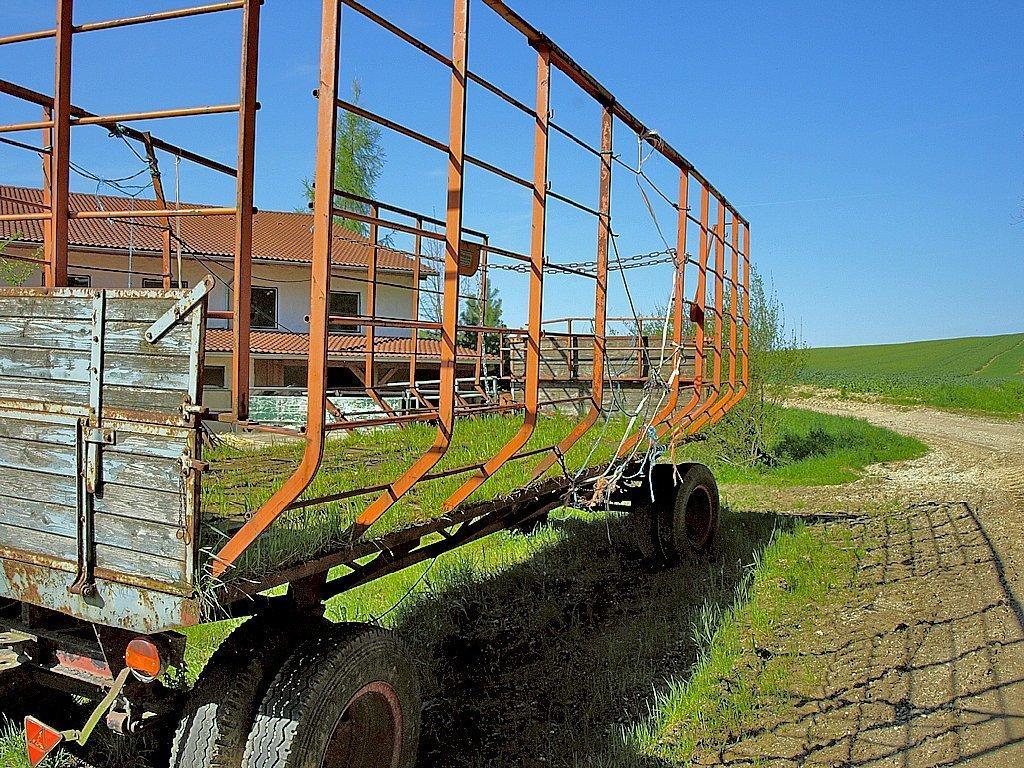Describe this image in one or two sentences. In this image I can see an open grass ground and in the front I can see a trolley. In the background I can see few trees, a building and the sky. 